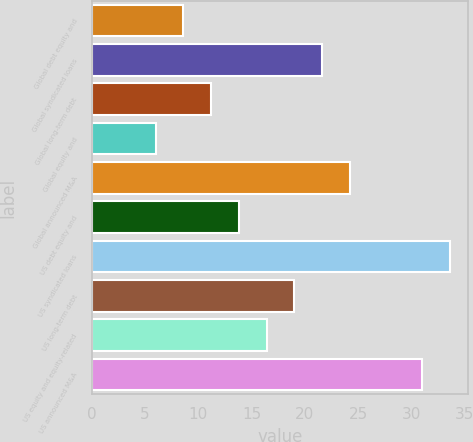Convert chart. <chart><loc_0><loc_0><loc_500><loc_500><bar_chart><fcel>Global debt equity and<fcel>Global syndicated loans<fcel>Global long-term debt<fcel>Global equity and<fcel>Global announced M&A<fcel>US debt equity and<fcel>US syndicated loans<fcel>US long-term debt<fcel>US equity and equity-related<fcel>US announced M&A<nl><fcel>8.6<fcel>21.6<fcel>11.2<fcel>6<fcel>24.2<fcel>13.8<fcel>33.6<fcel>19<fcel>16.4<fcel>31<nl></chart> 